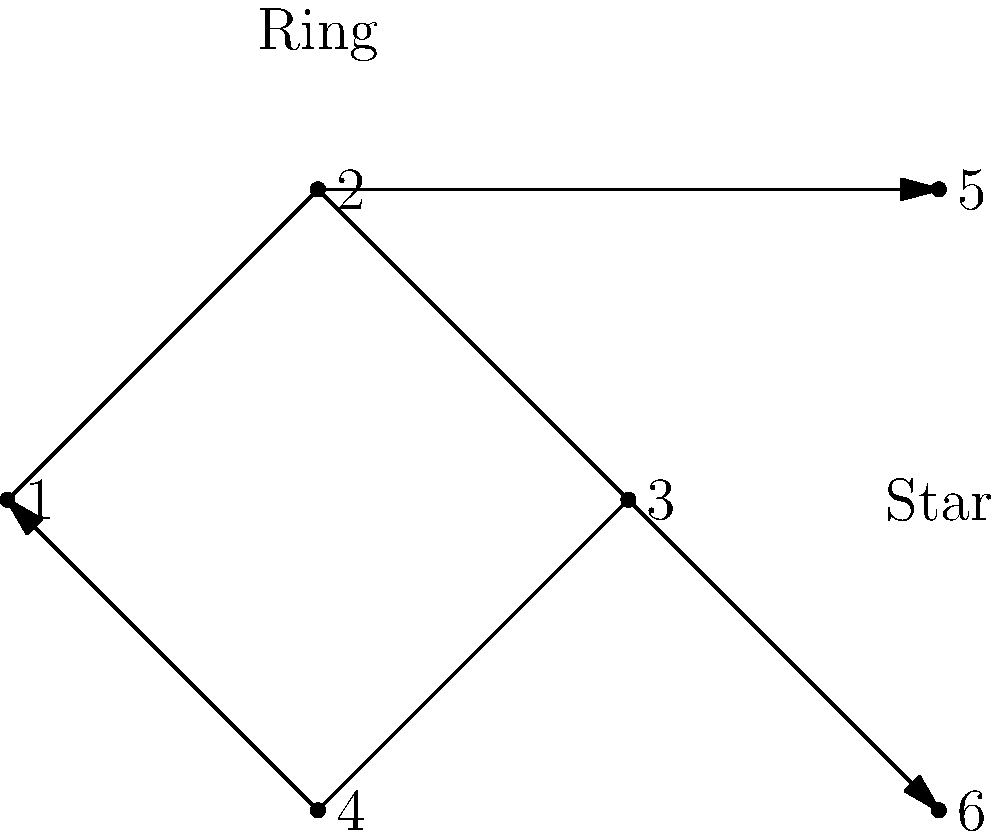In the network topology shown above, which configuration would result in the most efficient communication if node 1 needs to broadcast a message to all other nodes? Consider the number of hops required for the message to reach all nodes. To determine the most efficient configuration for broadcasting a message from node 1 to all other nodes, we need to analyze the number of hops required in each topology:

1. Ring topology (nodes 1, 2, 3, 4):
   - Node 1 to Node 2: 1 hop
   - Node 1 to Node 3: 2 hops
   - Node 1 to Node 4: 1 hop
   Maximum number of hops: 2

2. Star topology (nodes 1, 2, 5, 6):
   - Node 1 to Node 2: 1 hop
   - Node 1 to Node 5: 2 hops
   - Node 1 to Node 6: 2 hops
   Maximum number of hops: 2

However, in the star topology, node 1 would need to send the message to node 2 first, which would then forward it to nodes 5 and 6. This introduces an additional step in the process.

In the ring topology, node 1 can simultaneously send the message to nodes 2 and 4, which can then forward it to node 3. This parallel transmission reduces the overall time required for the message to reach all nodes.

Therefore, the ring topology would result in more efficient communication for broadcasting a message from node 1 to all other nodes.
Answer: Ring topology 